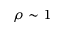<formula> <loc_0><loc_0><loc_500><loc_500>\rho \sim 1</formula> 